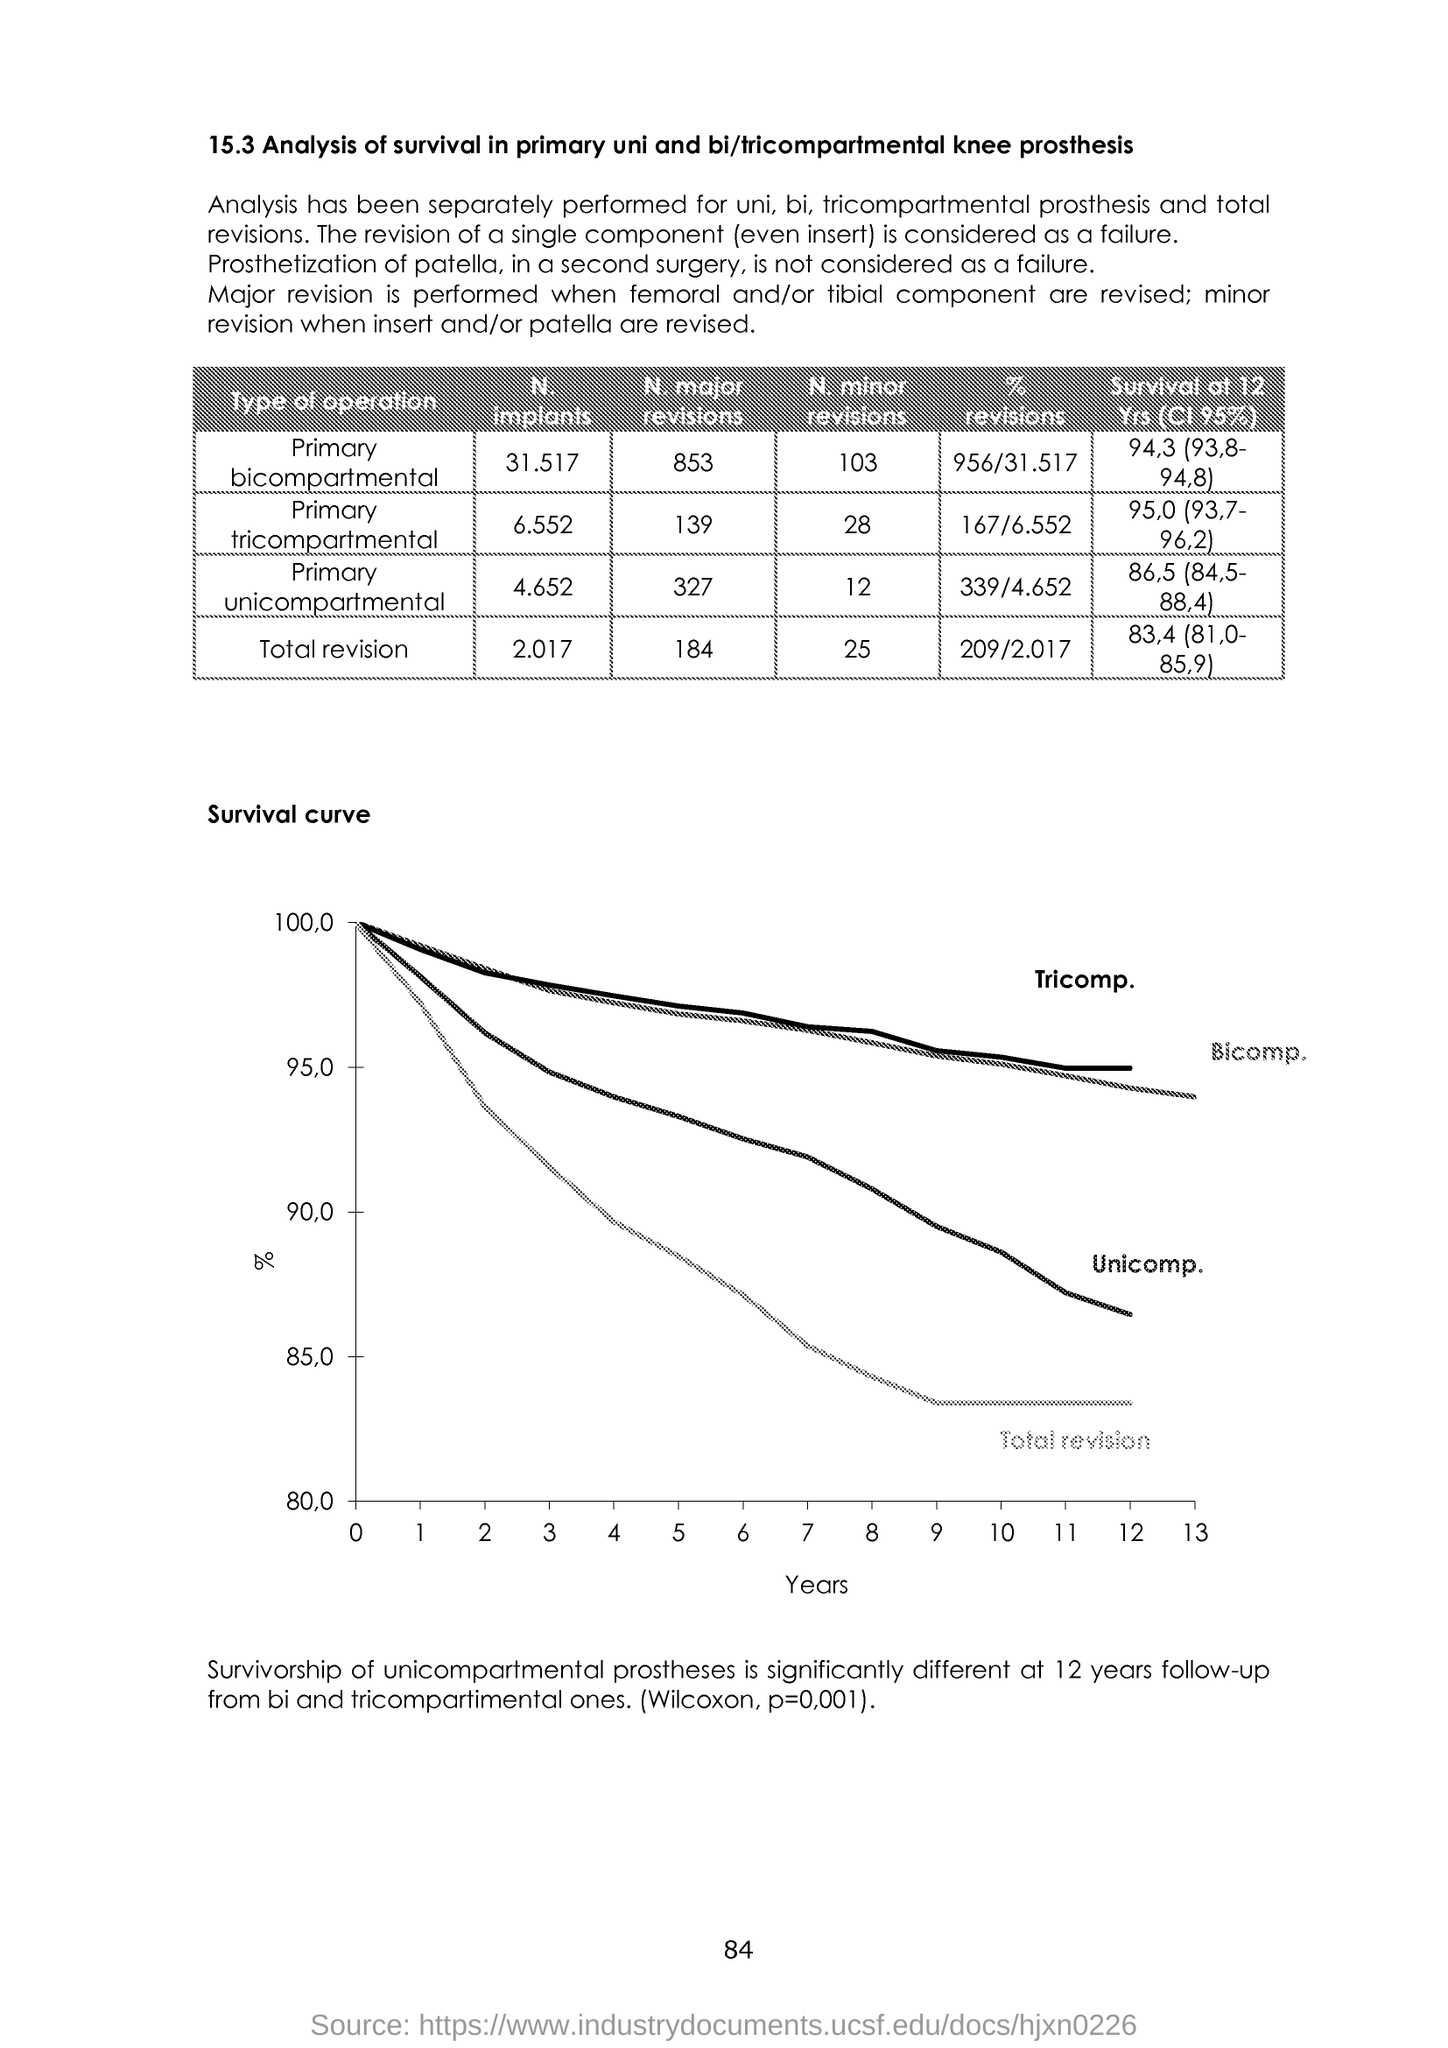What is plotted in the x-axis? The x-axis in the survival curve graph represents the timeline over which the data was collected, plotted in increments of 1 year, ranging from 0 to 13 years. 